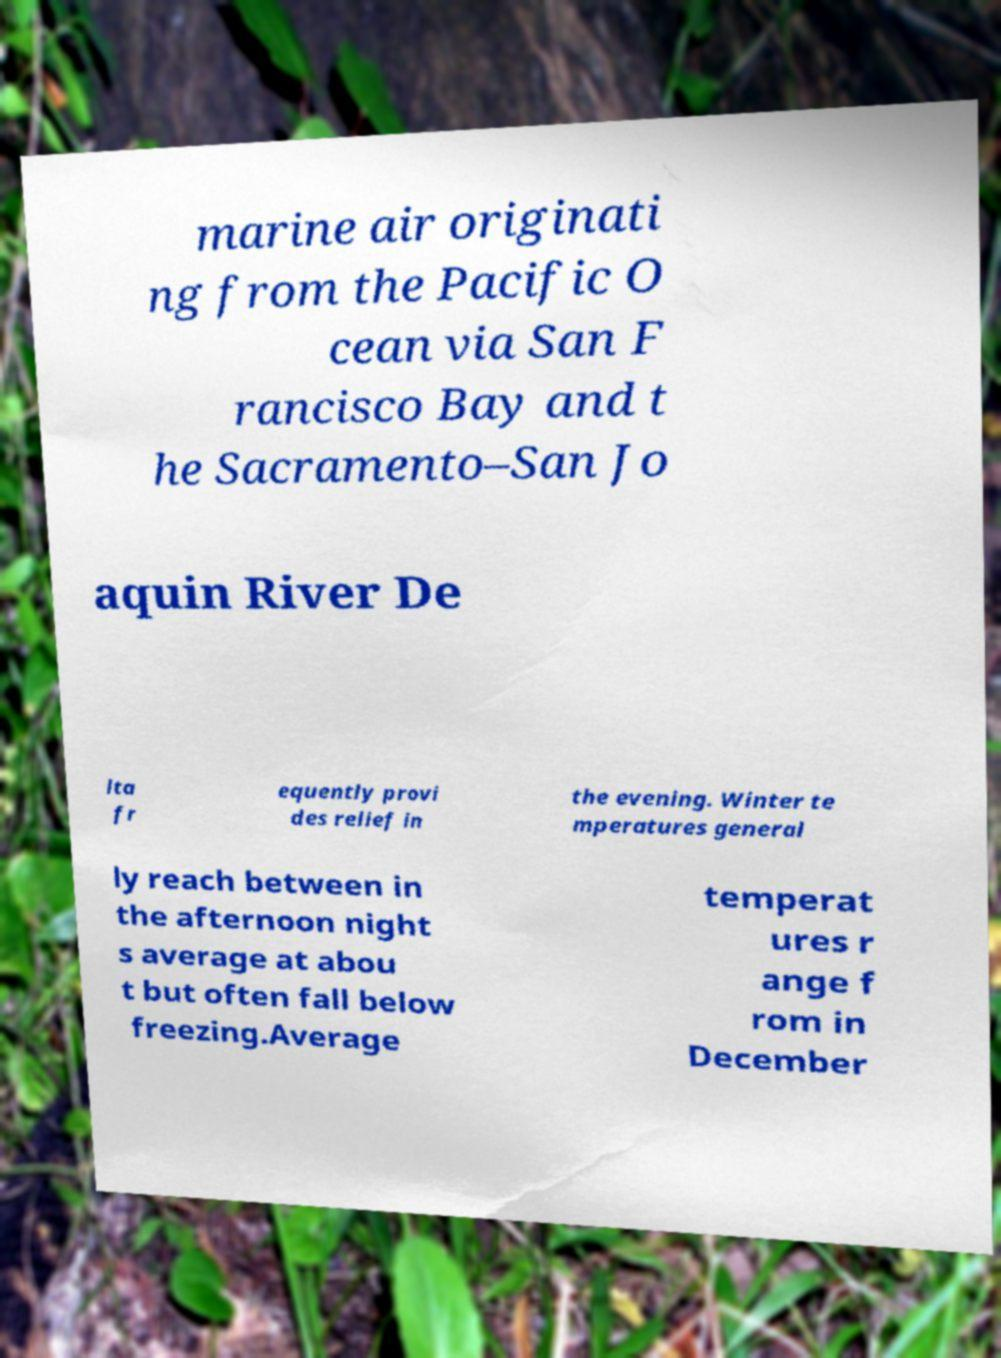Please read and relay the text visible in this image. What does it say? marine air originati ng from the Pacific O cean via San F rancisco Bay and t he Sacramento–San Jo aquin River De lta fr equently provi des relief in the evening. Winter te mperatures general ly reach between in the afternoon night s average at abou t but often fall below freezing.Average temperat ures r ange f rom in December 